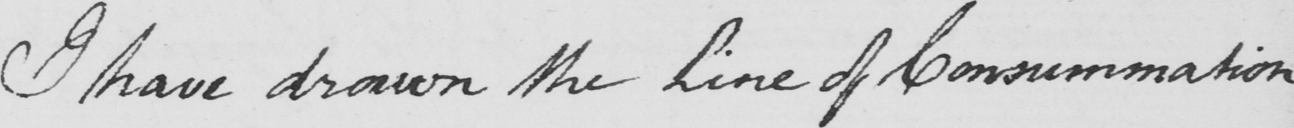Can you tell me what this handwritten text says? I have drawn the Line of Consummation 